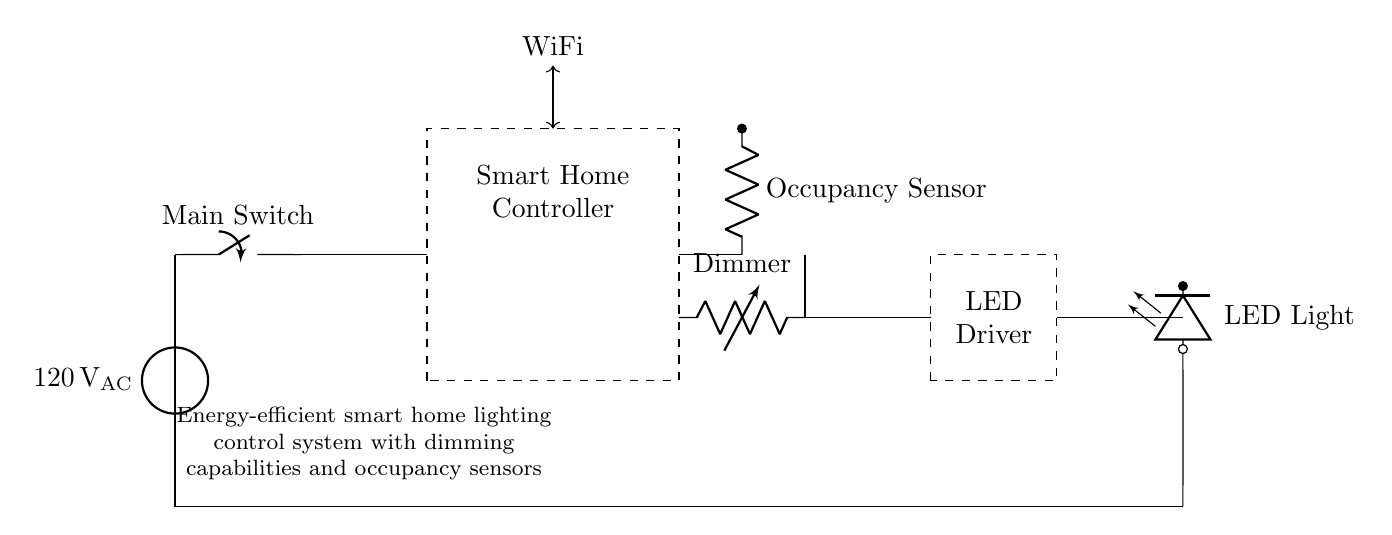What is the main voltage level in the circuit? The circuit operates at a voltage of one hundred twenty volts AC, as indicated near the power source symbol in the diagram.
Answer: one hundred twenty volts AC What component controls the lighting system? The Smart Home Controller manages the functioning of the lighting system, as denoted by the rectangle labeled as such in the circuit diagram.
Answer: Smart Home Controller What device detects occupancy in the system? The Occupancy Sensor is responsible for detecting whether someone is in the room, which is clearly marked in the diagram as a separate component labeled accordingly.
Answer: Occupancy Sensor How does the dimming function integrate into the circuit? The Dimmer is a device in the circuit that adjusts the brightness of the LED Light, connected in series and labeled explicitly in the diagram, making it integral to the dimming functionality.
Answer: Dimmer Which component drives the LED lights? The LED Driver provides the necessary current and voltage to the LED Light, as depicted by the dashed rectangle labeled LED Driver in the circuit.
Answer: LED Driver What role does WiFi play in this circuit? WiFi provides wireless connectivity for remote control and automation features, as indicated by the labeled arrow connecting the Smart Home Controller to the WiFi.
Answer: Remote control What is the function of the main switch in the circuit? The Main Switch controls the overall power supply to the circuit, allowing or interrupting the current flow from the power source to the rest of the components.
Answer: Power control 